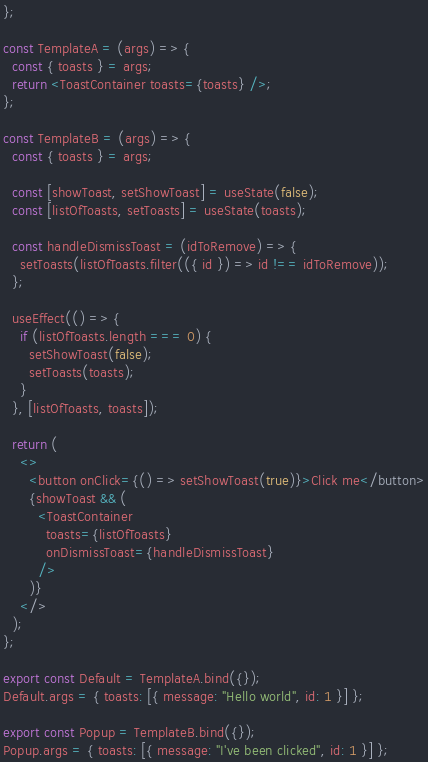<code> <loc_0><loc_0><loc_500><loc_500><_JavaScript_>};

const TemplateA = (args) => {
  const { toasts } = args;
  return <ToastContainer toasts={toasts} />;
};

const TemplateB = (args) => {
  const { toasts } = args;

  const [showToast, setShowToast] = useState(false);
  const [listOfToasts, setToasts] = useState(toasts);

  const handleDismissToast = (idToRemove) => {
    setToasts(listOfToasts.filter(({ id }) => id !== idToRemove));
  };

  useEffect(() => {
    if (listOfToasts.length === 0) {
      setShowToast(false);
      setToasts(toasts);
    }
  }, [listOfToasts, toasts]);

  return (
    <>
      <button onClick={() => setShowToast(true)}>Click me</button>
      {showToast && (
        <ToastContainer
          toasts={listOfToasts}
          onDismissToast={handleDismissToast}
        />
      )}
    </>
  );
};

export const Default = TemplateA.bind({});
Default.args = { toasts: [{ message: "Hello world", id: 1 }] };

export const Popup = TemplateB.bind({});
Popup.args = { toasts: [{ message: "I've been clicked", id: 1 }] };
</code> 